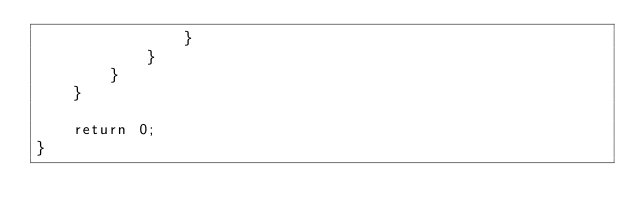Convert code to text. <code><loc_0><loc_0><loc_500><loc_500><_C++_>                }
            }
        }
    }

    return 0;
}
</code> 